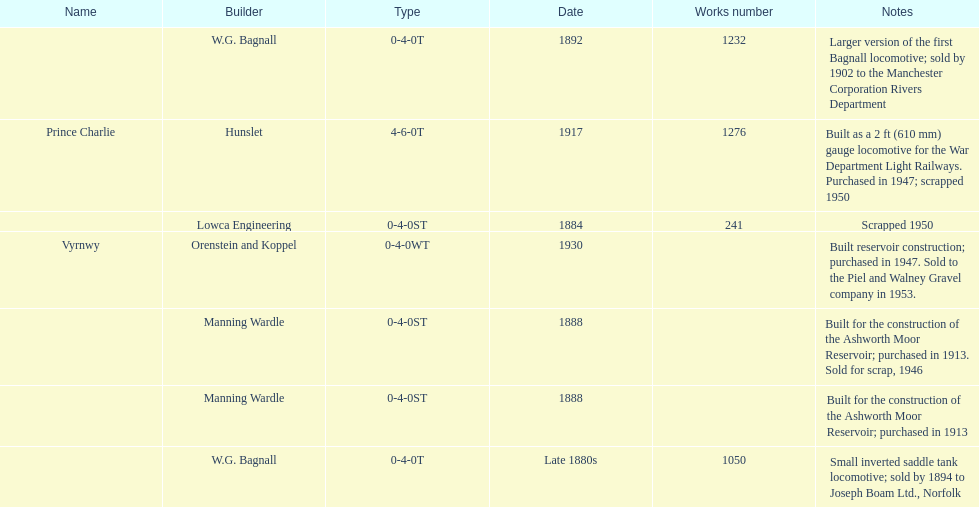How many locomotives were built before the 1900s? 5. 